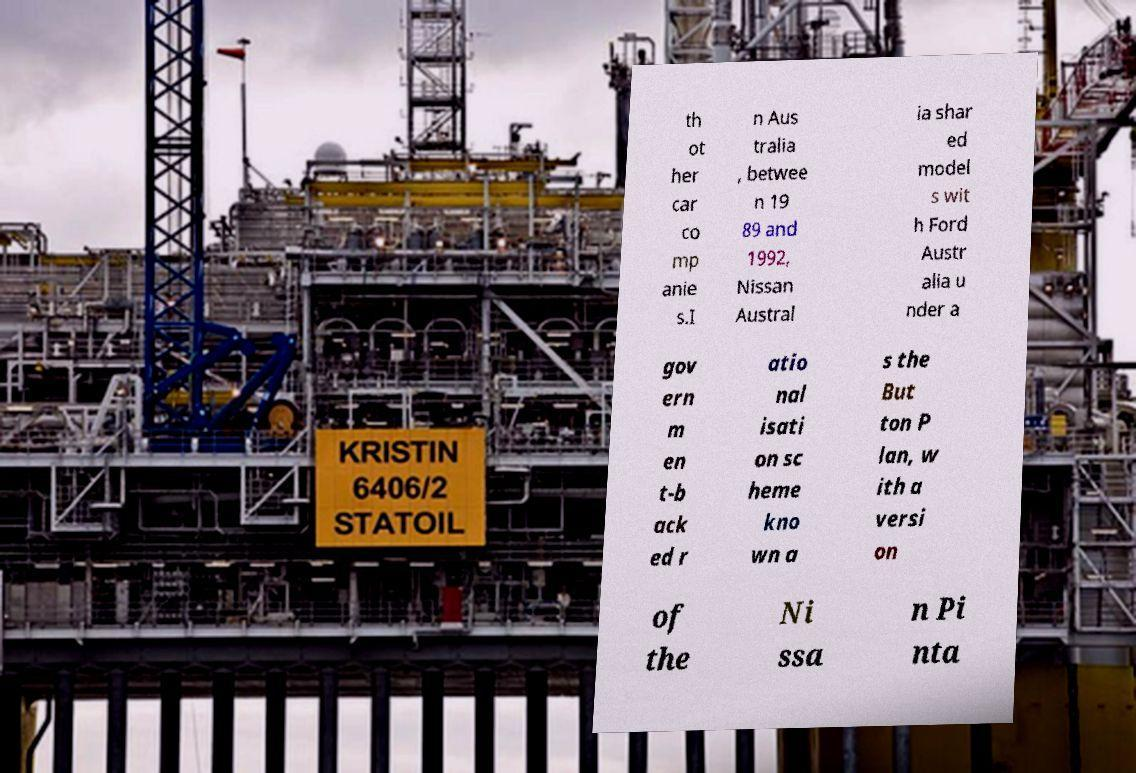For documentation purposes, I need the text within this image transcribed. Could you provide that? th ot her car co mp anie s.I n Aus tralia , betwee n 19 89 and 1992, Nissan Austral ia shar ed model s wit h Ford Austr alia u nder a gov ern m en t-b ack ed r atio nal isati on sc heme kno wn a s the But ton P lan, w ith a versi on of the Ni ssa n Pi nta 